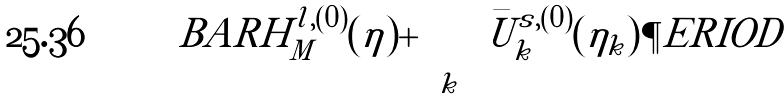<formula> <loc_0><loc_0><loc_500><loc_500>\ B A R H _ { M } ^ { l , ( 0 ) } ( \eta ) + \sum _ { k } \bar { U } ^ { s , ( 0 ) } _ { k } ( \eta _ { k } ) \P E R I O D</formula> 